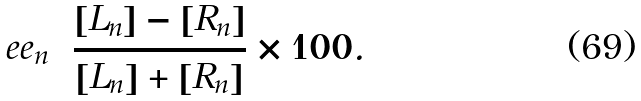<formula> <loc_0><loc_0><loc_500><loc_500>e e _ { n } = \frac { [ L _ { n } ] - [ R _ { n } ] } { [ L _ { n } ] + [ R _ { n } ] } \times 1 0 0 .</formula> 